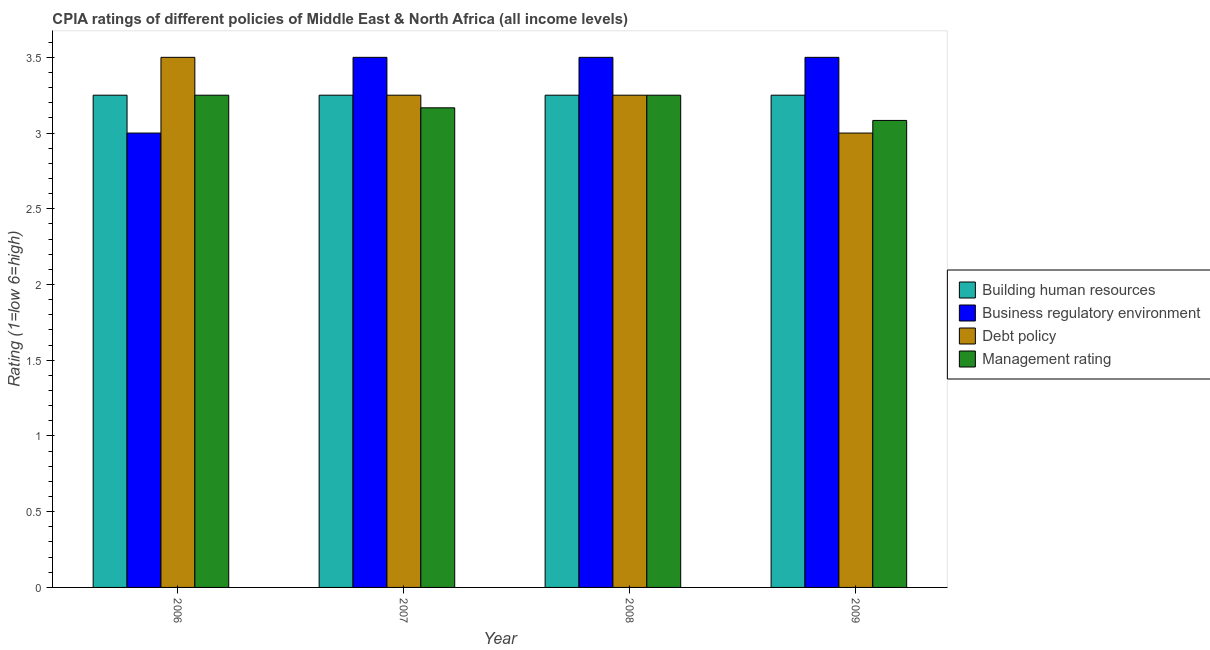How many different coloured bars are there?
Make the answer very short. 4. How many groups of bars are there?
Your response must be concise. 4. Are the number of bars per tick equal to the number of legend labels?
Keep it short and to the point. Yes. Are the number of bars on each tick of the X-axis equal?
Keep it short and to the point. Yes. How many bars are there on the 3rd tick from the left?
Ensure brevity in your answer.  4. What is the cpia rating of business regulatory environment in 2006?
Offer a terse response. 3. Across all years, what is the maximum cpia rating of building human resources?
Keep it short and to the point. 3.25. Across all years, what is the minimum cpia rating of management?
Your response must be concise. 3.08. In which year was the cpia rating of building human resources minimum?
Keep it short and to the point. 2006. What is the total cpia rating of business regulatory environment in the graph?
Offer a very short reply. 13.5. What is the difference between the cpia rating of debt policy in 2007 and that in 2009?
Provide a succinct answer. 0.25. What is the difference between the cpia rating of business regulatory environment in 2007 and the cpia rating of debt policy in 2006?
Your response must be concise. 0.5. What is the ratio of the cpia rating of business regulatory environment in 2007 to that in 2009?
Offer a very short reply. 1. What is the difference between the highest and the lowest cpia rating of management?
Your response must be concise. 0.17. What does the 1st bar from the left in 2009 represents?
Provide a succinct answer. Building human resources. What does the 4th bar from the right in 2006 represents?
Your response must be concise. Building human resources. Is it the case that in every year, the sum of the cpia rating of building human resources and cpia rating of business regulatory environment is greater than the cpia rating of debt policy?
Your answer should be compact. Yes. Are all the bars in the graph horizontal?
Ensure brevity in your answer.  No. How many years are there in the graph?
Provide a succinct answer. 4. What is the difference between two consecutive major ticks on the Y-axis?
Offer a terse response. 0.5. Are the values on the major ticks of Y-axis written in scientific E-notation?
Make the answer very short. No. Does the graph contain any zero values?
Provide a succinct answer. No. Does the graph contain grids?
Your response must be concise. No. How are the legend labels stacked?
Ensure brevity in your answer.  Vertical. What is the title of the graph?
Your answer should be very brief. CPIA ratings of different policies of Middle East & North Africa (all income levels). What is the Rating (1=low 6=high) in Business regulatory environment in 2006?
Offer a terse response. 3. What is the Rating (1=low 6=high) in Management rating in 2006?
Offer a terse response. 3.25. What is the Rating (1=low 6=high) in Management rating in 2007?
Offer a very short reply. 3.17. What is the Rating (1=low 6=high) in Building human resources in 2008?
Provide a short and direct response. 3.25. What is the Rating (1=low 6=high) in Management rating in 2008?
Your answer should be compact. 3.25. What is the Rating (1=low 6=high) in Building human resources in 2009?
Your answer should be very brief. 3.25. What is the Rating (1=low 6=high) in Business regulatory environment in 2009?
Ensure brevity in your answer.  3.5. What is the Rating (1=low 6=high) of Management rating in 2009?
Give a very brief answer. 3.08. Across all years, what is the maximum Rating (1=low 6=high) of Building human resources?
Provide a short and direct response. 3.25. Across all years, what is the maximum Rating (1=low 6=high) of Management rating?
Your answer should be very brief. 3.25. Across all years, what is the minimum Rating (1=low 6=high) in Building human resources?
Give a very brief answer. 3.25. Across all years, what is the minimum Rating (1=low 6=high) in Business regulatory environment?
Offer a very short reply. 3. Across all years, what is the minimum Rating (1=low 6=high) of Debt policy?
Provide a succinct answer. 3. Across all years, what is the minimum Rating (1=low 6=high) of Management rating?
Provide a short and direct response. 3.08. What is the total Rating (1=low 6=high) of Building human resources in the graph?
Provide a succinct answer. 13. What is the total Rating (1=low 6=high) of Business regulatory environment in the graph?
Ensure brevity in your answer.  13.5. What is the total Rating (1=low 6=high) of Debt policy in the graph?
Your answer should be very brief. 13. What is the total Rating (1=low 6=high) in Management rating in the graph?
Make the answer very short. 12.75. What is the difference between the Rating (1=low 6=high) in Business regulatory environment in 2006 and that in 2007?
Ensure brevity in your answer.  -0.5. What is the difference between the Rating (1=low 6=high) in Debt policy in 2006 and that in 2007?
Provide a short and direct response. 0.25. What is the difference between the Rating (1=low 6=high) of Management rating in 2006 and that in 2007?
Offer a terse response. 0.08. What is the difference between the Rating (1=low 6=high) in Building human resources in 2006 and that in 2008?
Offer a very short reply. 0. What is the difference between the Rating (1=low 6=high) in Business regulatory environment in 2006 and that in 2009?
Keep it short and to the point. -0.5. What is the difference between the Rating (1=low 6=high) in Debt policy in 2006 and that in 2009?
Keep it short and to the point. 0.5. What is the difference between the Rating (1=low 6=high) of Management rating in 2007 and that in 2008?
Offer a very short reply. -0.08. What is the difference between the Rating (1=low 6=high) of Management rating in 2007 and that in 2009?
Provide a succinct answer. 0.08. What is the difference between the Rating (1=low 6=high) of Business regulatory environment in 2008 and that in 2009?
Your answer should be very brief. 0. What is the difference between the Rating (1=low 6=high) of Management rating in 2008 and that in 2009?
Provide a succinct answer. 0.17. What is the difference between the Rating (1=low 6=high) of Building human resources in 2006 and the Rating (1=low 6=high) of Business regulatory environment in 2007?
Keep it short and to the point. -0.25. What is the difference between the Rating (1=low 6=high) in Building human resources in 2006 and the Rating (1=low 6=high) in Management rating in 2007?
Your answer should be very brief. 0.08. What is the difference between the Rating (1=low 6=high) of Business regulatory environment in 2006 and the Rating (1=low 6=high) of Debt policy in 2007?
Offer a terse response. -0.25. What is the difference between the Rating (1=low 6=high) of Debt policy in 2006 and the Rating (1=low 6=high) of Management rating in 2007?
Offer a terse response. 0.33. What is the difference between the Rating (1=low 6=high) in Building human resources in 2006 and the Rating (1=low 6=high) in Debt policy in 2008?
Ensure brevity in your answer.  0. What is the difference between the Rating (1=low 6=high) of Business regulatory environment in 2006 and the Rating (1=low 6=high) of Debt policy in 2008?
Your answer should be very brief. -0.25. What is the difference between the Rating (1=low 6=high) in Business regulatory environment in 2006 and the Rating (1=low 6=high) in Debt policy in 2009?
Give a very brief answer. 0. What is the difference between the Rating (1=low 6=high) of Business regulatory environment in 2006 and the Rating (1=low 6=high) of Management rating in 2009?
Provide a succinct answer. -0.08. What is the difference between the Rating (1=low 6=high) in Debt policy in 2006 and the Rating (1=low 6=high) in Management rating in 2009?
Offer a very short reply. 0.42. What is the difference between the Rating (1=low 6=high) of Building human resources in 2007 and the Rating (1=low 6=high) of Business regulatory environment in 2008?
Keep it short and to the point. -0.25. What is the difference between the Rating (1=low 6=high) in Building human resources in 2007 and the Rating (1=low 6=high) in Debt policy in 2008?
Your answer should be compact. 0. What is the difference between the Rating (1=low 6=high) of Business regulatory environment in 2007 and the Rating (1=low 6=high) of Management rating in 2008?
Offer a terse response. 0.25. What is the difference between the Rating (1=low 6=high) in Debt policy in 2007 and the Rating (1=low 6=high) in Management rating in 2008?
Offer a terse response. 0. What is the difference between the Rating (1=low 6=high) of Building human resources in 2007 and the Rating (1=low 6=high) of Debt policy in 2009?
Give a very brief answer. 0.25. What is the difference between the Rating (1=low 6=high) in Building human resources in 2007 and the Rating (1=low 6=high) in Management rating in 2009?
Offer a very short reply. 0.17. What is the difference between the Rating (1=low 6=high) of Business regulatory environment in 2007 and the Rating (1=low 6=high) of Management rating in 2009?
Provide a short and direct response. 0.42. What is the difference between the Rating (1=low 6=high) in Building human resources in 2008 and the Rating (1=low 6=high) in Management rating in 2009?
Provide a succinct answer. 0.17. What is the difference between the Rating (1=low 6=high) of Business regulatory environment in 2008 and the Rating (1=low 6=high) of Debt policy in 2009?
Your response must be concise. 0.5. What is the difference between the Rating (1=low 6=high) in Business regulatory environment in 2008 and the Rating (1=low 6=high) in Management rating in 2009?
Ensure brevity in your answer.  0.42. What is the difference between the Rating (1=low 6=high) in Debt policy in 2008 and the Rating (1=low 6=high) in Management rating in 2009?
Your response must be concise. 0.17. What is the average Rating (1=low 6=high) of Business regulatory environment per year?
Ensure brevity in your answer.  3.38. What is the average Rating (1=low 6=high) in Debt policy per year?
Ensure brevity in your answer.  3.25. What is the average Rating (1=low 6=high) of Management rating per year?
Your answer should be very brief. 3.19. In the year 2006, what is the difference between the Rating (1=low 6=high) of Building human resources and Rating (1=low 6=high) of Business regulatory environment?
Provide a short and direct response. 0.25. In the year 2006, what is the difference between the Rating (1=low 6=high) of Building human resources and Rating (1=low 6=high) of Management rating?
Offer a terse response. 0. In the year 2006, what is the difference between the Rating (1=low 6=high) of Business regulatory environment and Rating (1=low 6=high) of Debt policy?
Your answer should be compact. -0.5. In the year 2006, what is the difference between the Rating (1=low 6=high) in Business regulatory environment and Rating (1=low 6=high) in Management rating?
Your answer should be very brief. -0.25. In the year 2007, what is the difference between the Rating (1=low 6=high) of Building human resources and Rating (1=low 6=high) of Business regulatory environment?
Make the answer very short. -0.25. In the year 2007, what is the difference between the Rating (1=low 6=high) of Building human resources and Rating (1=low 6=high) of Debt policy?
Offer a terse response. 0. In the year 2007, what is the difference between the Rating (1=low 6=high) of Building human resources and Rating (1=low 6=high) of Management rating?
Make the answer very short. 0.08. In the year 2007, what is the difference between the Rating (1=low 6=high) in Debt policy and Rating (1=low 6=high) in Management rating?
Give a very brief answer. 0.08. In the year 2008, what is the difference between the Rating (1=low 6=high) of Building human resources and Rating (1=low 6=high) of Business regulatory environment?
Offer a terse response. -0.25. In the year 2008, what is the difference between the Rating (1=low 6=high) in Building human resources and Rating (1=low 6=high) in Debt policy?
Offer a very short reply. 0. In the year 2008, what is the difference between the Rating (1=low 6=high) in Building human resources and Rating (1=low 6=high) in Management rating?
Your answer should be very brief. 0. In the year 2008, what is the difference between the Rating (1=low 6=high) of Debt policy and Rating (1=low 6=high) of Management rating?
Provide a short and direct response. 0. In the year 2009, what is the difference between the Rating (1=low 6=high) in Building human resources and Rating (1=low 6=high) in Management rating?
Your answer should be compact. 0.17. In the year 2009, what is the difference between the Rating (1=low 6=high) in Business regulatory environment and Rating (1=low 6=high) in Management rating?
Keep it short and to the point. 0.42. In the year 2009, what is the difference between the Rating (1=low 6=high) of Debt policy and Rating (1=low 6=high) of Management rating?
Keep it short and to the point. -0.08. What is the ratio of the Rating (1=low 6=high) of Business regulatory environment in 2006 to that in 2007?
Keep it short and to the point. 0.86. What is the ratio of the Rating (1=low 6=high) in Debt policy in 2006 to that in 2007?
Your answer should be very brief. 1.08. What is the ratio of the Rating (1=low 6=high) in Management rating in 2006 to that in 2007?
Ensure brevity in your answer.  1.03. What is the ratio of the Rating (1=low 6=high) in Business regulatory environment in 2006 to that in 2008?
Make the answer very short. 0.86. What is the ratio of the Rating (1=low 6=high) in Management rating in 2006 to that in 2008?
Your answer should be compact. 1. What is the ratio of the Rating (1=low 6=high) in Building human resources in 2006 to that in 2009?
Offer a terse response. 1. What is the ratio of the Rating (1=low 6=high) of Debt policy in 2006 to that in 2009?
Make the answer very short. 1.17. What is the ratio of the Rating (1=low 6=high) of Management rating in 2006 to that in 2009?
Your response must be concise. 1.05. What is the ratio of the Rating (1=low 6=high) of Business regulatory environment in 2007 to that in 2008?
Your answer should be compact. 1. What is the ratio of the Rating (1=low 6=high) in Debt policy in 2007 to that in 2008?
Keep it short and to the point. 1. What is the ratio of the Rating (1=low 6=high) in Management rating in 2007 to that in 2008?
Provide a short and direct response. 0.97. What is the ratio of the Rating (1=low 6=high) in Business regulatory environment in 2007 to that in 2009?
Offer a terse response. 1. What is the ratio of the Rating (1=low 6=high) in Debt policy in 2007 to that in 2009?
Your response must be concise. 1.08. What is the ratio of the Rating (1=low 6=high) of Building human resources in 2008 to that in 2009?
Provide a succinct answer. 1. What is the ratio of the Rating (1=low 6=high) in Business regulatory environment in 2008 to that in 2009?
Provide a short and direct response. 1. What is the ratio of the Rating (1=low 6=high) in Management rating in 2008 to that in 2009?
Make the answer very short. 1.05. What is the difference between the highest and the second highest Rating (1=low 6=high) in Business regulatory environment?
Provide a succinct answer. 0. What is the difference between the highest and the second highest Rating (1=low 6=high) of Management rating?
Give a very brief answer. 0. What is the difference between the highest and the lowest Rating (1=low 6=high) of Building human resources?
Make the answer very short. 0. 